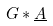Convert formula to latex. <formula><loc_0><loc_0><loc_500><loc_500>G * \underline { A }</formula> 